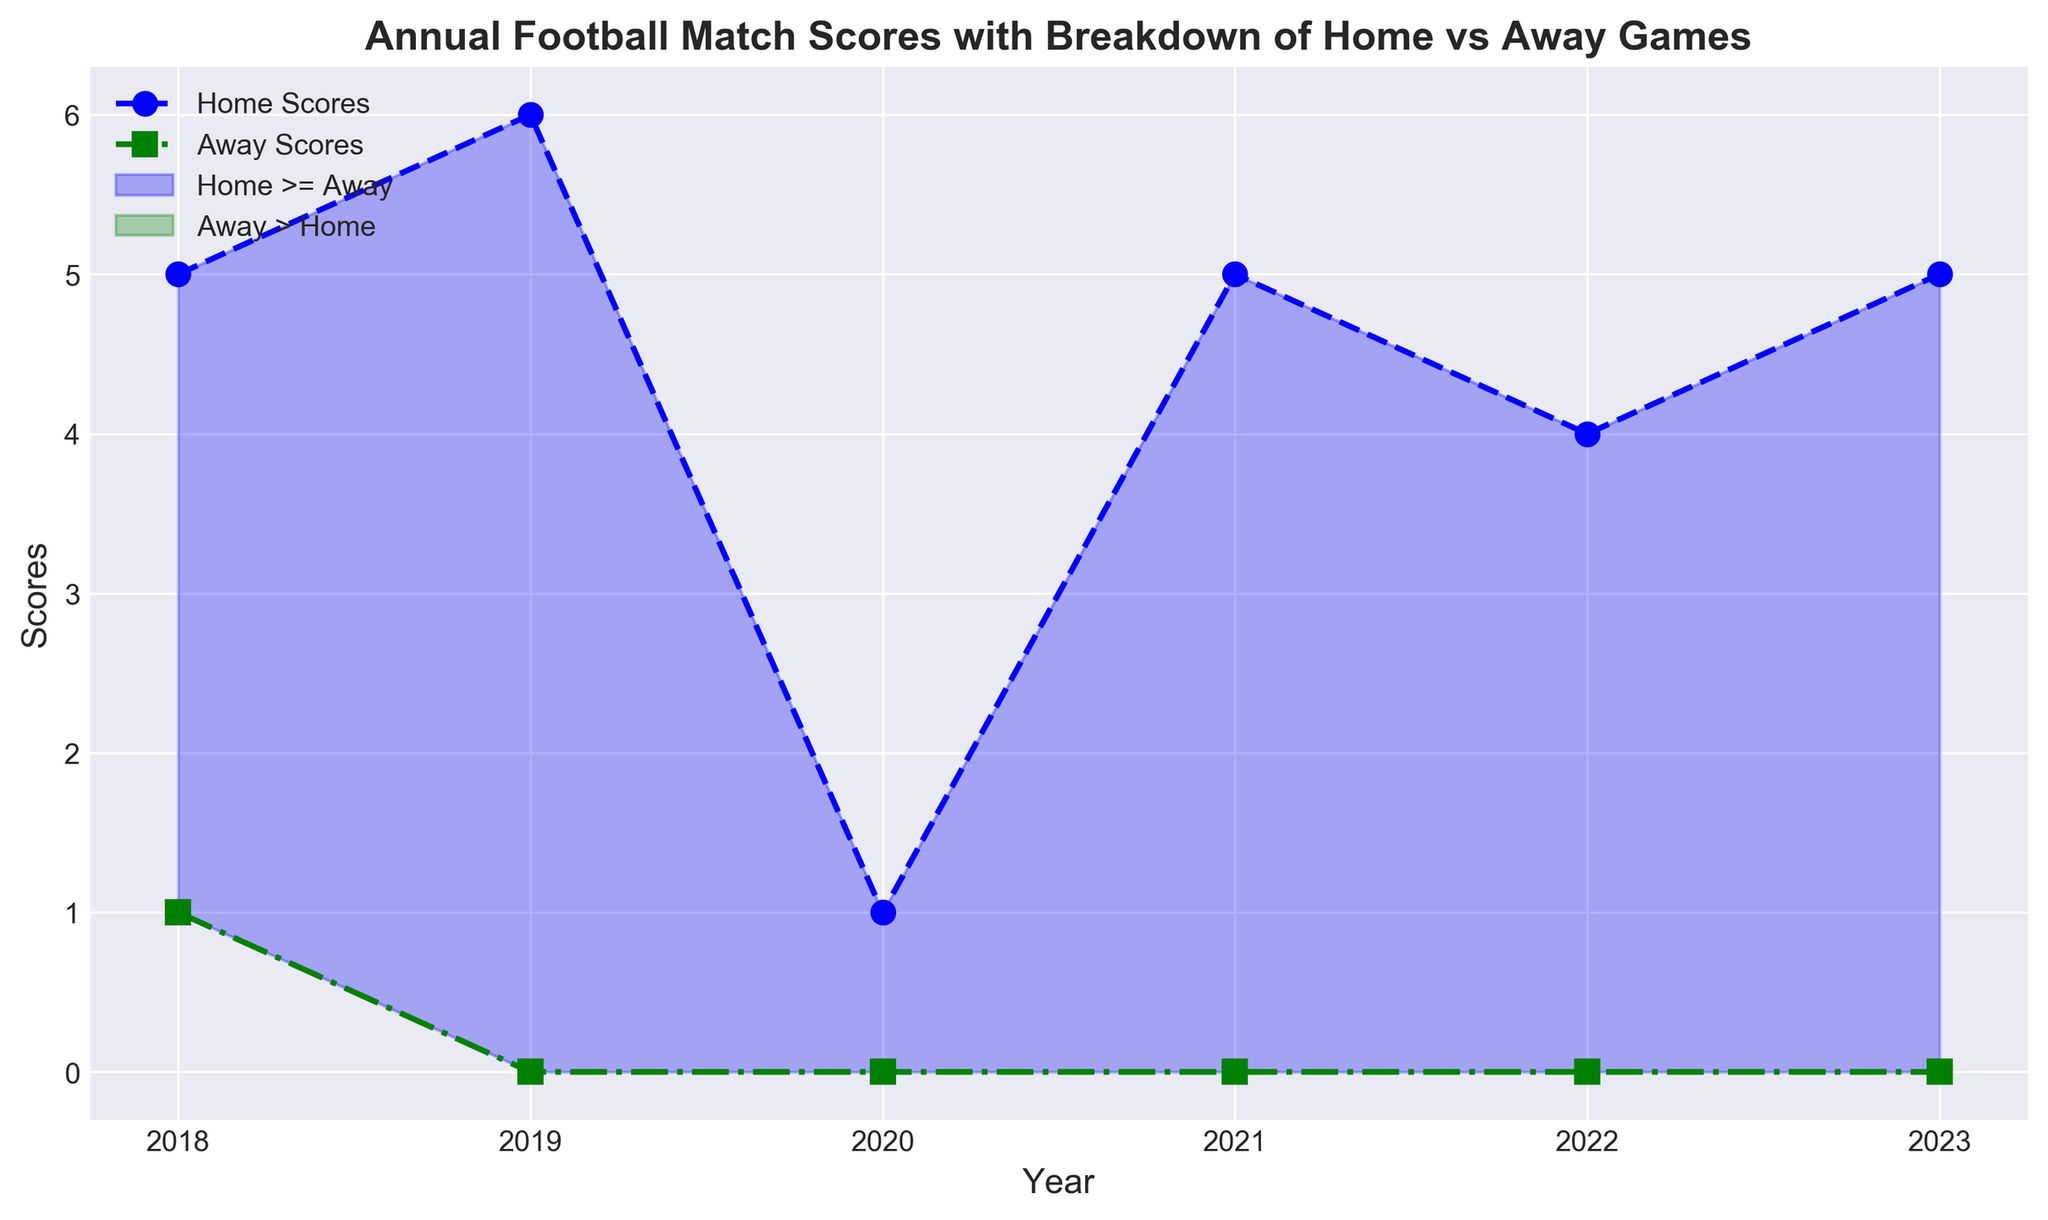Which year had the highest total home scores? By inspecting the peaks of the blue line on the chart, identify the highest point.
Answer: 2023 Which year had the lowest total away scores? By examining the troughs of the green line on the chart, find the lowest point.
Answer: 2021 Which year had a higher home score than away score? Identify the segments where the blue shaded area ('Home >= Away') appears above the green shaded area ('Away > Home').
Answer: 2019, 2020, 2023 In which year did the away scores exceed the home scores the most? Check the green shaded areas where away scores lead by the largest margin over home scores.
Answer: 2021 What is the difference between home and away scores in 2020? Look at the blue and green lines at the year 2020 and subtract the away score from the home score to find the difference.
Answer: 3 When did home scores first surpass away scores after 2018? Identify the earliest point after 2018 where the blue line is above the green line.
Answer: 2019 Between which years was there no recorded away score? Check the years on the green line that are flat at zero points.
Answer: 2018, 2021 Which years had both home and away scores equal? Identify years where the blue and green lines intersect.
Answer: 2022 By how much did the home scores change from 2018 to 2021? Calculate the difference by subtracting the 2018 home score from the 2021 home score.
Answer: -3 Which year showed the largest increase in away scores compared to the previous year? Determine the year-to-year increments for the green line and find the largest positive change.
Answer: 2020 